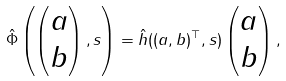Convert formula to latex. <formula><loc_0><loc_0><loc_500><loc_500>\hat { \Phi } \left ( \begin{pmatrix} a \\ b \end{pmatrix} , s \right ) = \hat { h } ( ( a , b ) ^ { \top } , s ) \begin{pmatrix} a \\ b \end{pmatrix} ,</formula> 